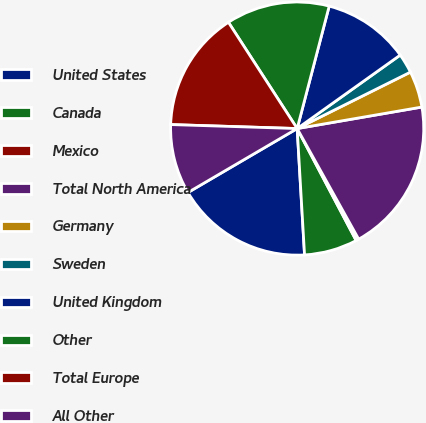<chart> <loc_0><loc_0><loc_500><loc_500><pie_chart><fcel>United States<fcel>Canada<fcel>Mexico<fcel>Total North America<fcel>Germany<fcel>Sweden<fcel>United Kingdom<fcel>Other<fcel>Total Europe<fcel>All Other<nl><fcel>17.5%<fcel>6.79%<fcel>0.36%<fcel>19.64%<fcel>4.64%<fcel>2.5%<fcel>11.07%<fcel>13.21%<fcel>15.36%<fcel>8.93%<nl></chart> 